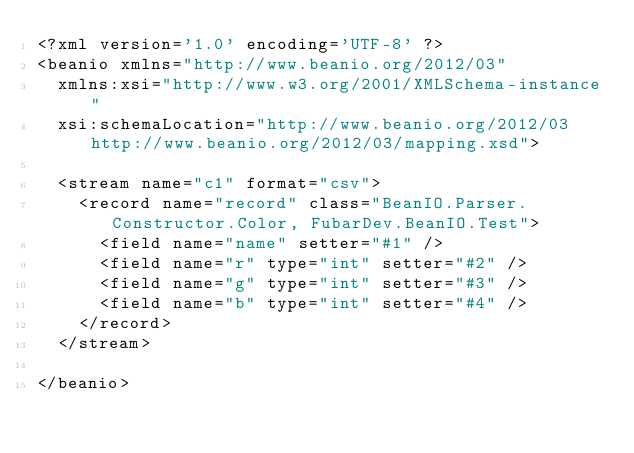<code> <loc_0><loc_0><loc_500><loc_500><_XML_><?xml version='1.0' encoding='UTF-8' ?>
<beanio xmlns="http://www.beanio.org/2012/03" 
  xmlns:xsi="http://www.w3.org/2001/XMLSchema-instance"
  xsi:schemaLocation="http://www.beanio.org/2012/03 http://www.beanio.org/2012/03/mapping.xsd">

  <stream name="c1" format="csv">
    <record name="record" class="BeanIO.Parser.Constructor.Color, FubarDev.BeanIO.Test">
      <field name="name" setter="#1" />
      <field name="r" type="int" setter="#2" />
      <field name="g" type="int" setter="#3" />
      <field name="b" type="int" setter="#4" />
    </record>
  </stream>
  
</beanio></code> 